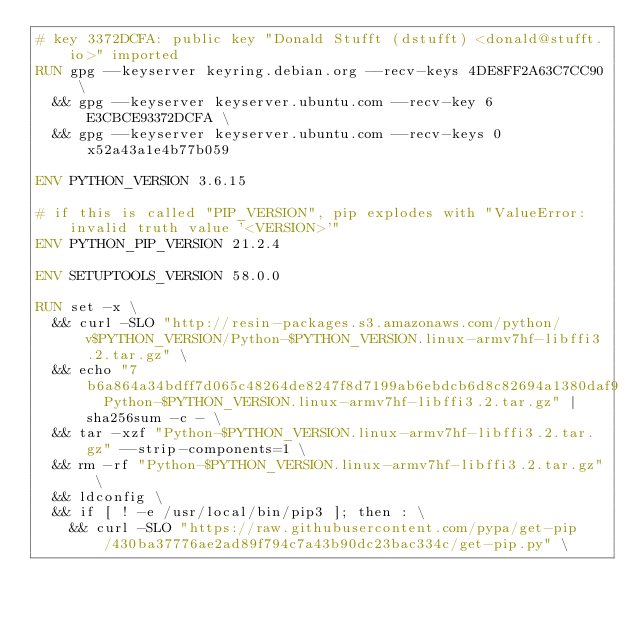<code> <loc_0><loc_0><loc_500><loc_500><_Dockerfile_># key 3372DCFA: public key "Donald Stufft (dstufft) <donald@stufft.io>" imported
RUN gpg --keyserver keyring.debian.org --recv-keys 4DE8FF2A63C7CC90 \
	&& gpg --keyserver keyserver.ubuntu.com --recv-key 6E3CBCE93372DCFA \
	&& gpg --keyserver keyserver.ubuntu.com --recv-keys 0x52a43a1e4b77b059

ENV PYTHON_VERSION 3.6.15

# if this is called "PIP_VERSION", pip explodes with "ValueError: invalid truth value '<VERSION>'"
ENV PYTHON_PIP_VERSION 21.2.4

ENV SETUPTOOLS_VERSION 58.0.0

RUN set -x \
	&& curl -SLO "http://resin-packages.s3.amazonaws.com/python/v$PYTHON_VERSION/Python-$PYTHON_VERSION.linux-armv7hf-libffi3.2.tar.gz" \
	&& echo "7b6a864a34bdff7d065c48264de8247f8d7199ab6ebdcb6d8c82694a1380daf9  Python-$PYTHON_VERSION.linux-armv7hf-libffi3.2.tar.gz" | sha256sum -c - \
	&& tar -xzf "Python-$PYTHON_VERSION.linux-armv7hf-libffi3.2.tar.gz" --strip-components=1 \
	&& rm -rf "Python-$PYTHON_VERSION.linux-armv7hf-libffi3.2.tar.gz" \
	&& ldconfig \
	&& if [ ! -e /usr/local/bin/pip3 ]; then : \
		&& curl -SLO "https://raw.githubusercontent.com/pypa/get-pip/430ba37776ae2ad89f794c7a43b90dc23bac334c/get-pip.py" \</code> 